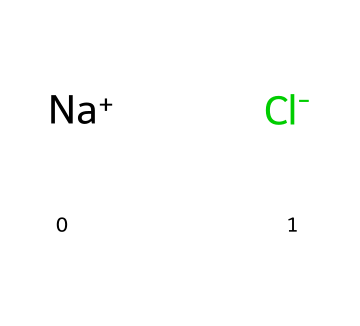What is the chemical name of the drug represented by this SMILES? The SMILES represents a compound consisting of a sodium ion and a chloride ion along with a complex organic structure that can be identified as an analog of a well-known drug. This specific structure corresponds to a drug used in lethal injections, typically called "pentobarbital."
Answer: pentobarbital How many nitrogen atoms are present in the compound? By analyzing the SMILES notation, we can identify the presence of nitrogen atoms in the cyclic structure. There are two nitrogen atoms present in the cyclic ring.
Answer: 2 What ions are indicated in the chemical structure? The SMILES representation shows [Na+] and [Cl-] as the ions present in the compound, indicating the presence of sodium and chloride ions.
Answer: sodium and chloride How many rings are present in the structure? By evaluating the structure represented in the SMILES, I can see that there are two distinct cyclic structures in the compound (the two heptagonal-like components), which indicates the presence of fused rings.
Answer: 2 What is the primary use of this drug in human applications? This drug is commonly used as an anesthetic and sedative, especially in end-of-life situations, and is part of the lethal injection protocol used in euthanasia and capital punishment.
Answer: anesthetic What type of drug classification does this compound fall under? Given the structure, this compound is classified as a barbiturate, which is significant in its use for inducing sedation and anesthesia, including in lethal injections.
Answer: barbiturate What ethical concerns are associated with the use of this compound in lethal injections? The primary ethical concern revolves around the moral implications of using such drugs for capital punishment and the potential for causing suffering or ineffective procedures.
Answer: moral implications 